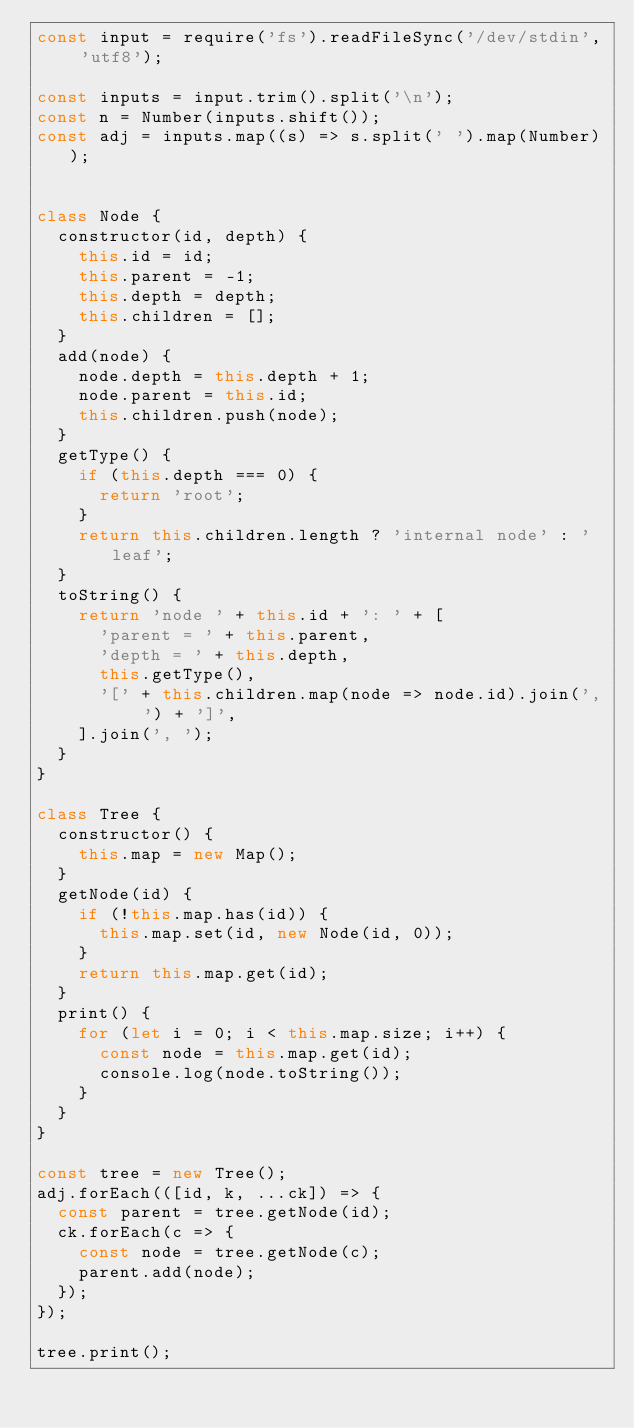Convert code to text. <code><loc_0><loc_0><loc_500><loc_500><_JavaScript_>const input = require('fs').readFileSync('/dev/stdin', 'utf8');

const inputs = input.trim().split('\n');
const n = Number(inputs.shift());
const adj = inputs.map((s) => s.split(' ').map(Number));


class Node {
  constructor(id, depth) {
    this.id = id;
    this.parent = -1;
    this.depth = depth;
    this.children = [];
  }
  add(node) {
    node.depth = this.depth + 1;
    node.parent = this.id;
    this.children.push(node);
  }
  getType() {
    if (this.depth === 0) {
      return 'root';
    }
    return this.children.length ? 'internal node' : 'leaf';
  }
  toString() {
    return 'node ' + this.id + ': ' + [
      'parent = ' + this.parent,
      'depth = ' + this.depth,
      this.getType(),
      '[' + this.children.map(node => node.id).join(', ') + ']',
    ].join(', ');
  }
}

class Tree {
  constructor() {
    this.map = new Map();
  }
  getNode(id) {
    if (!this.map.has(id)) {
      this.map.set(id, new Node(id, 0));
    }
    return this.map.get(id);
  }
  print() {
    for (let i = 0; i < this.map.size; i++) {
      const node = this.map.get(id);
      console.log(node.toString());
    }
  }
}

const tree = new Tree();
adj.forEach(([id, k, ...ck]) => {
  const parent = tree.getNode(id);
  ck.forEach(c => {
    const node = tree.getNode(c);
    parent.add(node);
  });
});

tree.print();

</code> 